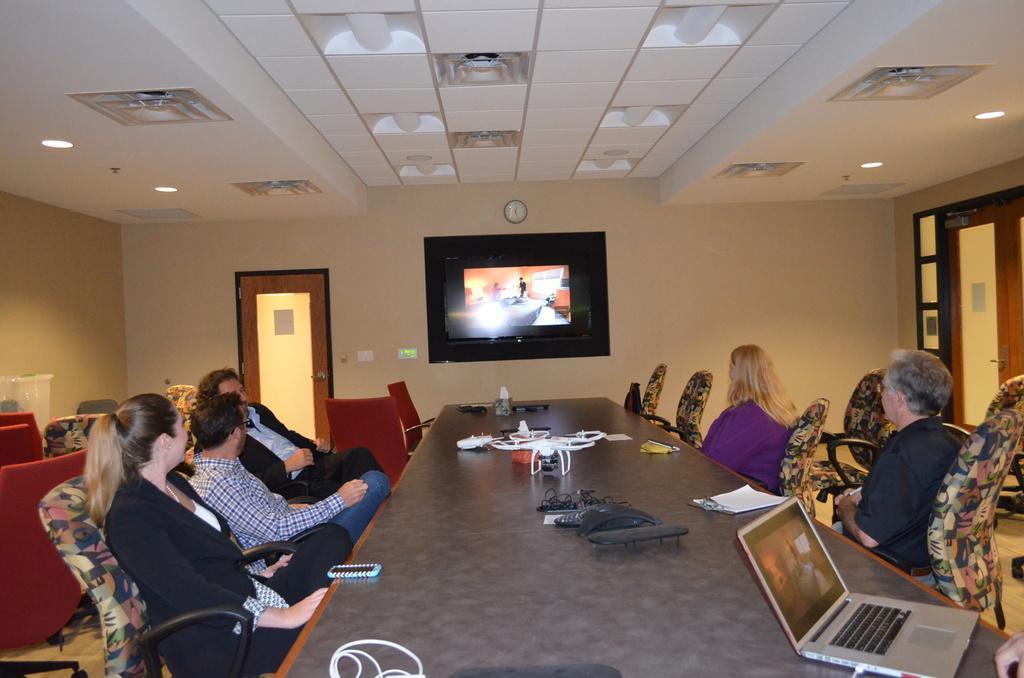How would you summarize this image in a sentence or two? In this image there are group of people who are sitting on chairs, and in front of them there is a table. On the table there are some wires, phones, laptop and some other objects. In the center there is a television on the wall, and on the right side and left side there are doors and on the left side there are some chairs and some objects. At the top there is ceiling and some lights. 